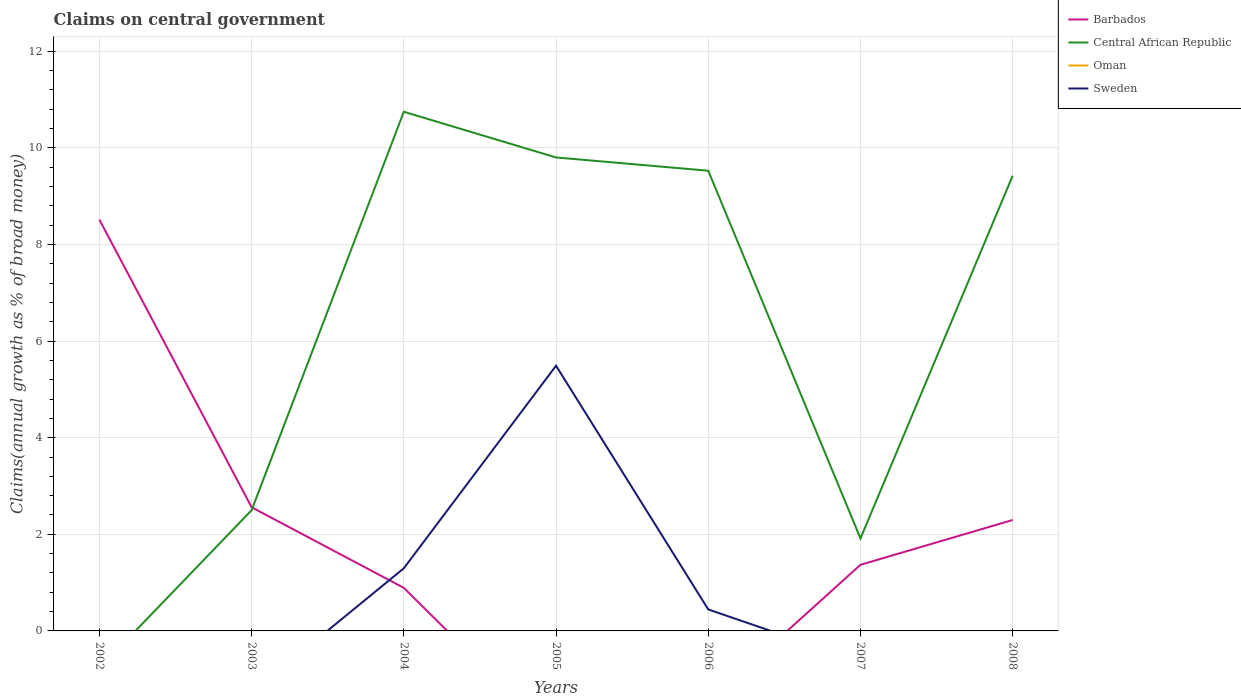Does the line corresponding to Central African Republic intersect with the line corresponding to Oman?
Provide a succinct answer. No. Is the number of lines equal to the number of legend labels?
Your answer should be compact. No. What is the total percentage of broad money claimed on centeral government in Barbados in the graph?
Make the answer very short. 5.95. What is the difference between the highest and the second highest percentage of broad money claimed on centeral government in Barbados?
Your answer should be compact. 8.51. What is the difference between the highest and the lowest percentage of broad money claimed on centeral government in Oman?
Provide a short and direct response. 0. Is the percentage of broad money claimed on centeral government in Barbados strictly greater than the percentage of broad money claimed on centeral government in Sweden over the years?
Offer a very short reply. No. How many lines are there?
Provide a succinct answer. 3. Are the values on the major ticks of Y-axis written in scientific E-notation?
Offer a very short reply. No. How many legend labels are there?
Give a very brief answer. 4. How are the legend labels stacked?
Make the answer very short. Vertical. What is the title of the graph?
Your response must be concise. Claims on central government. What is the label or title of the X-axis?
Make the answer very short. Years. What is the label or title of the Y-axis?
Your answer should be very brief. Claims(annual growth as % of broad money). What is the Claims(annual growth as % of broad money) in Barbados in 2002?
Provide a short and direct response. 8.51. What is the Claims(annual growth as % of broad money) of Central African Republic in 2002?
Your answer should be compact. 0. What is the Claims(annual growth as % of broad money) in Barbados in 2003?
Keep it short and to the point. 2.56. What is the Claims(annual growth as % of broad money) of Central African Republic in 2003?
Your answer should be very brief. 2.5. What is the Claims(annual growth as % of broad money) in Barbados in 2004?
Offer a terse response. 0.89. What is the Claims(annual growth as % of broad money) of Central African Republic in 2004?
Ensure brevity in your answer.  10.75. What is the Claims(annual growth as % of broad money) of Sweden in 2004?
Provide a short and direct response. 1.3. What is the Claims(annual growth as % of broad money) of Central African Republic in 2005?
Your answer should be very brief. 9.8. What is the Claims(annual growth as % of broad money) in Sweden in 2005?
Your answer should be compact. 5.49. What is the Claims(annual growth as % of broad money) of Barbados in 2006?
Offer a very short reply. 0. What is the Claims(annual growth as % of broad money) of Central African Republic in 2006?
Provide a succinct answer. 9.53. What is the Claims(annual growth as % of broad money) of Sweden in 2006?
Your answer should be compact. 0.44. What is the Claims(annual growth as % of broad money) in Barbados in 2007?
Your answer should be very brief. 1.37. What is the Claims(annual growth as % of broad money) of Central African Republic in 2007?
Give a very brief answer. 1.91. What is the Claims(annual growth as % of broad money) of Sweden in 2007?
Your response must be concise. 0. What is the Claims(annual growth as % of broad money) in Barbados in 2008?
Your answer should be compact. 2.3. What is the Claims(annual growth as % of broad money) in Central African Republic in 2008?
Provide a short and direct response. 9.42. What is the Claims(annual growth as % of broad money) of Oman in 2008?
Offer a very short reply. 0. What is the Claims(annual growth as % of broad money) of Sweden in 2008?
Provide a succinct answer. 0. Across all years, what is the maximum Claims(annual growth as % of broad money) in Barbados?
Provide a short and direct response. 8.51. Across all years, what is the maximum Claims(annual growth as % of broad money) in Central African Republic?
Provide a succinct answer. 10.75. Across all years, what is the maximum Claims(annual growth as % of broad money) of Sweden?
Offer a very short reply. 5.49. Across all years, what is the minimum Claims(annual growth as % of broad money) of Barbados?
Provide a succinct answer. 0. Across all years, what is the minimum Claims(annual growth as % of broad money) of Central African Republic?
Give a very brief answer. 0. What is the total Claims(annual growth as % of broad money) in Barbados in the graph?
Offer a very short reply. 15.63. What is the total Claims(annual growth as % of broad money) in Central African Republic in the graph?
Your answer should be compact. 43.91. What is the total Claims(annual growth as % of broad money) in Sweden in the graph?
Offer a terse response. 7.23. What is the difference between the Claims(annual growth as % of broad money) of Barbados in 2002 and that in 2003?
Give a very brief answer. 5.95. What is the difference between the Claims(annual growth as % of broad money) of Barbados in 2002 and that in 2004?
Provide a short and direct response. 7.62. What is the difference between the Claims(annual growth as % of broad money) of Barbados in 2002 and that in 2007?
Ensure brevity in your answer.  7.15. What is the difference between the Claims(annual growth as % of broad money) of Barbados in 2002 and that in 2008?
Your response must be concise. 6.22. What is the difference between the Claims(annual growth as % of broad money) in Barbados in 2003 and that in 2004?
Make the answer very short. 1.67. What is the difference between the Claims(annual growth as % of broad money) of Central African Republic in 2003 and that in 2004?
Make the answer very short. -8.25. What is the difference between the Claims(annual growth as % of broad money) in Central African Republic in 2003 and that in 2005?
Make the answer very short. -7.3. What is the difference between the Claims(annual growth as % of broad money) of Central African Republic in 2003 and that in 2006?
Offer a very short reply. -7.03. What is the difference between the Claims(annual growth as % of broad money) in Barbados in 2003 and that in 2007?
Keep it short and to the point. 1.19. What is the difference between the Claims(annual growth as % of broad money) of Central African Republic in 2003 and that in 2007?
Your answer should be very brief. 0.58. What is the difference between the Claims(annual growth as % of broad money) of Barbados in 2003 and that in 2008?
Give a very brief answer. 0.26. What is the difference between the Claims(annual growth as % of broad money) of Central African Republic in 2003 and that in 2008?
Offer a terse response. -6.93. What is the difference between the Claims(annual growth as % of broad money) of Central African Republic in 2004 and that in 2005?
Your answer should be very brief. 0.95. What is the difference between the Claims(annual growth as % of broad money) in Sweden in 2004 and that in 2005?
Provide a short and direct response. -4.19. What is the difference between the Claims(annual growth as % of broad money) of Central African Republic in 2004 and that in 2006?
Provide a short and direct response. 1.22. What is the difference between the Claims(annual growth as % of broad money) in Sweden in 2004 and that in 2006?
Give a very brief answer. 0.85. What is the difference between the Claims(annual growth as % of broad money) in Barbados in 2004 and that in 2007?
Keep it short and to the point. -0.48. What is the difference between the Claims(annual growth as % of broad money) of Central African Republic in 2004 and that in 2007?
Provide a succinct answer. 8.83. What is the difference between the Claims(annual growth as % of broad money) of Barbados in 2004 and that in 2008?
Give a very brief answer. -1.4. What is the difference between the Claims(annual growth as % of broad money) of Central African Republic in 2004 and that in 2008?
Provide a succinct answer. 1.32. What is the difference between the Claims(annual growth as % of broad money) of Central African Republic in 2005 and that in 2006?
Provide a succinct answer. 0.27. What is the difference between the Claims(annual growth as % of broad money) in Sweden in 2005 and that in 2006?
Provide a short and direct response. 5.04. What is the difference between the Claims(annual growth as % of broad money) of Central African Republic in 2005 and that in 2007?
Offer a terse response. 7.89. What is the difference between the Claims(annual growth as % of broad money) in Central African Republic in 2005 and that in 2008?
Offer a very short reply. 0.38. What is the difference between the Claims(annual growth as % of broad money) in Central African Republic in 2006 and that in 2007?
Ensure brevity in your answer.  7.61. What is the difference between the Claims(annual growth as % of broad money) in Central African Republic in 2006 and that in 2008?
Provide a short and direct response. 0.1. What is the difference between the Claims(annual growth as % of broad money) of Barbados in 2007 and that in 2008?
Offer a very short reply. -0.93. What is the difference between the Claims(annual growth as % of broad money) in Central African Republic in 2007 and that in 2008?
Provide a short and direct response. -7.51. What is the difference between the Claims(annual growth as % of broad money) in Barbados in 2002 and the Claims(annual growth as % of broad money) in Central African Republic in 2003?
Provide a short and direct response. 6.02. What is the difference between the Claims(annual growth as % of broad money) of Barbados in 2002 and the Claims(annual growth as % of broad money) of Central African Republic in 2004?
Provide a short and direct response. -2.23. What is the difference between the Claims(annual growth as % of broad money) of Barbados in 2002 and the Claims(annual growth as % of broad money) of Sweden in 2004?
Make the answer very short. 7.22. What is the difference between the Claims(annual growth as % of broad money) in Barbados in 2002 and the Claims(annual growth as % of broad money) in Central African Republic in 2005?
Provide a succinct answer. -1.29. What is the difference between the Claims(annual growth as % of broad money) of Barbados in 2002 and the Claims(annual growth as % of broad money) of Sweden in 2005?
Ensure brevity in your answer.  3.02. What is the difference between the Claims(annual growth as % of broad money) of Barbados in 2002 and the Claims(annual growth as % of broad money) of Central African Republic in 2006?
Keep it short and to the point. -1.01. What is the difference between the Claims(annual growth as % of broad money) in Barbados in 2002 and the Claims(annual growth as % of broad money) in Sweden in 2006?
Provide a succinct answer. 8.07. What is the difference between the Claims(annual growth as % of broad money) of Barbados in 2002 and the Claims(annual growth as % of broad money) of Central African Republic in 2007?
Give a very brief answer. 6.6. What is the difference between the Claims(annual growth as % of broad money) in Barbados in 2002 and the Claims(annual growth as % of broad money) in Central African Republic in 2008?
Provide a short and direct response. -0.91. What is the difference between the Claims(annual growth as % of broad money) of Barbados in 2003 and the Claims(annual growth as % of broad money) of Central African Republic in 2004?
Provide a short and direct response. -8.19. What is the difference between the Claims(annual growth as % of broad money) in Barbados in 2003 and the Claims(annual growth as % of broad money) in Sweden in 2004?
Ensure brevity in your answer.  1.26. What is the difference between the Claims(annual growth as % of broad money) of Central African Republic in 2003 and the Claims(annual growth as % of broad money) of Sweden in 2004?
Give a very brief answer. 1.2. What is the difference between the Claims(annual growth as % of broad money) in Barbados in 2003 and the Claims(annual growth as % of broad money) in Central African Republic in 2005?
Your answer should be very brief. -7.24. What is the difference between the Claims(annual growth as % of broad money) in Barbados in 2003 and the Claims(annual growth as % of broad money) in Sweden in 2005?
Your response must be concise. -2.93. What is the difference between the Claims(annual growth as % of broad money) of Central African Republic in 2003 and the Claims(annual growth as % of broad money) of Sweden in 2005?
Make the answer very short. -2.99. What is the difference between the Claims(annual growth as % of broad money) of Barbados in 2003 and the Claims(annual growth as % of broad money) of Central African Republic in 2006?
Provide a succinct answer. -6.97. What is the difference between the Claims(annual growth as % of broad money) of Barbados in 2003 and the Claims(annual growth as % of broad money) of Sweden in 2006?
Your response must be concise. 2.12. What is the difference between the Claims(annual growth as % of broad money) in Central African Republic in 2003 and the Claims(annual growth as % of broad money) in Sweden in 2006?
Ensure brevity in your answer.  2.05. What is the difference between the Claims(annual growth as % of broad money) in Barbados in 2003 and the Claims(annual growth as % of broad money) in Central African Republic in 2007?
Make the answer very short. 0.65. What is the difference between the Claims(annual growth as % of broad money) of Barbados in 2003 and the Claims(annual growth as % of broad money) of Central African Republic in 2008?
Offer a terse response. -6.86. What is the difference between the Claims(annual growth as % of broad money) in Barbados in 2004 and the Claims(annual growth as % of broad money) in Central African Republic in 2005?
Make the answer very short. -8.91. What is the difference between the Claims(annual growth as % of broad money) of Barbados in 2004 and the Claims(annual growth as % of broad money) of Sweden in 2005?
Provide a succinct answer. -4.6. What is the difference between the Claims(annual growth as % of broad money) of Central African Republic in 2004 and the Claims(annual growth as % of broad money) of Sweden in 2005?
Your answer should be compact. 5.26. What is the difference between the Claims(annual growth as % of broad money) in Barbados in 2004 and the Claims(annual growth as % of broad money) in Central African Republic in 2006?
Your answer should be very brief. -8.64. What is the difference between the Claims(annual growth as % of broad money) of Barbados in 2004 and the Claims(annual growth as % of broad money) of Sweden in 2006?
Keep it short and to the point. 0.45. What is the difference between the Claims(annual growth as % of broad money) of Central African Republic in 2004 and the Claims(annual growth as % of broad money) of Sweden in 2006?
Your response must be concise. 10.3. What is the difference between the Claims(annual growth as % of broad money) of Barbados in 2004 and the Claims(annual growth as % of broad money) of Central African Republic in 2007?
Make the answer very short. -1.02. What is the difference between the Claims(annual growth as % of broad money) in Barbados in 2004 and the Claims(annual growth as % of broad money) in Central African Republic in 2008?
Ensure brevity in your answer.  -8.53. What is the difference between the Claims(annual growth as % of broad money) of Central African Republic in 2005 and the Claims(annual growth as % of broad money) of Sweden in 2006?
Your answer should be compact. 9.36. What is the difference between the Claims(annual growth as % of broad money) in Barbados in 2007 and the Claims(annual growth as % of broad money) in Central African Republic in 2008?
Keep it short and to the point. -8.05. What is the average Claims(annual growth as % of broad money) of Barbados per year?
Provide a short and direct response. 2.23. What is the average Claims(annual growth as % of broad money) in Central African Republic per year?
Your answer should be very brief. 6.27. What is the average Claims(annual growth as % of broad money) of Sweden per year?
Offer a very short reply. 1.03. In the year 2003, what is the difference between the Claims(annual growth as % of broad money) of Barbados and Claims(annual growth as % of broad money) of Central African Republic?
Provide a succinct answer. 0.06. In the year 2004, what is the difference between the Claims(annual growth as % of broad money) in Barbados and Claims(annual growth as % of broad money) in Central African Republic?
Provide a succinct answer. -9.86. In the year 2004, what is the difference between the Claims(annual growth as % of broad money) in Barbados and Claims(annual growth as % of broad money) in Sweden?
Your answer should be very brief. -0.4. In the year 2004, what is the difference between the Claims(annual growth as % of broad money) of Central African Republic and Claims(annual growth as % of broad money) of Sweden?
Your response must be concise. 9.45. In the year 2005, what is the difference between the Claims(annual growth as % of broad money) in Central African Republic and Claims(annual growth as % of broad money) in Sweden?
Your answer should be very brief. 4.31. In the year 2006, what is the difference between the Claims(annual growth as % of broad money) in Central African Republic and Claims(annual growth as % of broad money) in Sweden?
Keep it short and to the point. 9.08. In the year 2007, what is the difference between the Claims(annual growth as % of broad money) in Barbados and Claims(annual growth as % of broad money) in Central African Republic?
Ensure brevity in your answer.  -0.55. In the year 2008, what is the difference between the Claims(annual growth as % of broad money) in Barbados and Claims(annual growth as % of broad money) in Central African Republic?
Ensure brevity in your answer.  -7.13. What is the ratio of the Claims(annual growth as % of broad money) in Barbados in 2002 to that in 2003?
Provide a succinct answer. 3.33. What is the ratio of the Claims(annual growth as % of broad money) in Barbados in 2002 to that in 2004?
Keep it short and to the point. 9.55. What is the ratio of the Claims(annual growth as % of broad money) of Barbados in 2002 to that in 2007?
Offer a terse response. 6.22. What is the ratio of the Claims(annual growth as % of broad money) of Barbados in 2002 to that in 2008?
Provide a succinct answer. 3.71. What is the ratio of the Claims(annual growth as % of broad money) of Barbados in 2003 to that in 2004?
Your answer should be very brief. 2.87. What is the ratio of the Claims(annual growth as % of broad money) of Central African Republic in 2003 to that in 2004?
Ensure brevity in your answer.  0.23. What is the ratio of the Claims(annual growth as % of broad money) of Central African Republic in 2003 to that in 2005?
Keep it short and to the point. 0.25. What is the ratio of the Claims(annual growth as % of broad money) in Central African Republic in 2003 to that in 2006?
Make the answer very short. 0.26. What is the ratio of the Claims(annual growth as % of broad money) of Barbados in 2003 to that in 2007?
Your answer should be compact. 1.87. What is the ratio of the Claims(annual growth as % of broad money) in Central African Republic in 2003 to that in 2007?
Provide a short and direct response. 1.31. What is the ratio of the Claims(annual growth as % of broad money) in Barbados in 2003 to that in 2008?
Give a very brief answer. 1.11. What is the ratio of the Claims(annual growth as % of broad money) in Central African Republic in 2003 to that in 2008?
Make the answer very short. 0.27. What is the ratio of the Claims(annual growth as % of broad money) of Central African Republic in 2004 to that in 2005?
Make the answer very short. 1.1. What is the ratio of the Claims(annual growth as % of broad money) of Sweden in 2004 to that in 2005?
Offer a very short reply. 0.24. What is the ratio of the Claims(annual growth as % of broad money) of Central African Republic in 2004 to that in 2006?
Provide a succinct answer. 1.13. What is the ratio of the Claims(annual growth as % of broad money) of Sweden in 2004 to that in 2006?
Make the answer very short. 2.91. What is the ratio of the Claims(annual growth as % of broad money) in Barbados in 2004 to that in 2007?
Give a very brief answer. 0.65. What is the ratio of the Claims(annual growth as % of broad money) of Central African Republic in 2004 to that in 2007?
Provide a succinct answer. 5.61. What is the ratio of the Claims(annual growth as % of broad money) in Barbados in 2004 to that in 2008?
Your answer should be very brief. 0.39. What is the ratio of the Claims(annual growth as % of broad money) in Central African Republic in 2004 to that in 2008?
Make the answer very short. 1.14. What is the ratio of the Claims(annual growth as % of broad money) of Central African Republic in 2005 to that in 2006?
Provide a succinct answer. 1.03. What is the ratio of the Claims(annual growth as % of broad money) of Sweden in 2005 to that in 2006?
Your response must be concise. 12.34. What is the ratio of the Claims(annual growth as % of broad money) in Central African Republic in 2005 to that in 2007?
Offer a very short reply. 5.12. What is the ratio of the Claims(annual growth as % of broad money) of Central African Republic in 2005 to that in 2008?
Your response must be concise. 1.04. What is the ratio of the Claims(annual growth as % of broad money) in Central African Republic in 2006 to that in 2007?
Make the answer very short. 4.98. What is the ratio of the Claims(annual growth as % of broad money) in Central African Republic in 2006 to that in 2008?
Make the answer very short. 1.01. What is the ratio of the Claims(annual growth as % of broad money) in Barbados in 2007 to that in 2008?
Offer a very short reply. 0.6. What is the ratio of the Claims(annual growth as % of broad money) in Central African Republic in 2007 to that in 2008?
Provide a short and direct response. 0.2. What is the difference between the highest and the second highest Claims(annual growth as % of broad money) of Barbados?
Offer a very short reply. 5.95. What is the difference between the highest and the second highest Claims(annual growth as % of broad money) in Central African Republic?
Your response must be concise. 0.95. What is the difference between the highest and the second highest Claims(annual growth as % of broad money) in Sweden?
Your answer should be compact. 4.19. What is the difference between the highest and the lowest Claims(annual growth as % of broad money) of Barbados?
Offer a very short reply. 8.51. What is the difference between the highest and the lowest Claims(annual growth as % of broad money) in Central African Republic?
Offer a very short reply. 10.75. What is the difference between the highest and the lowest Claims(annual growth as % of broad money) in Sweden?
Your answer should be very brief. 5.49. 